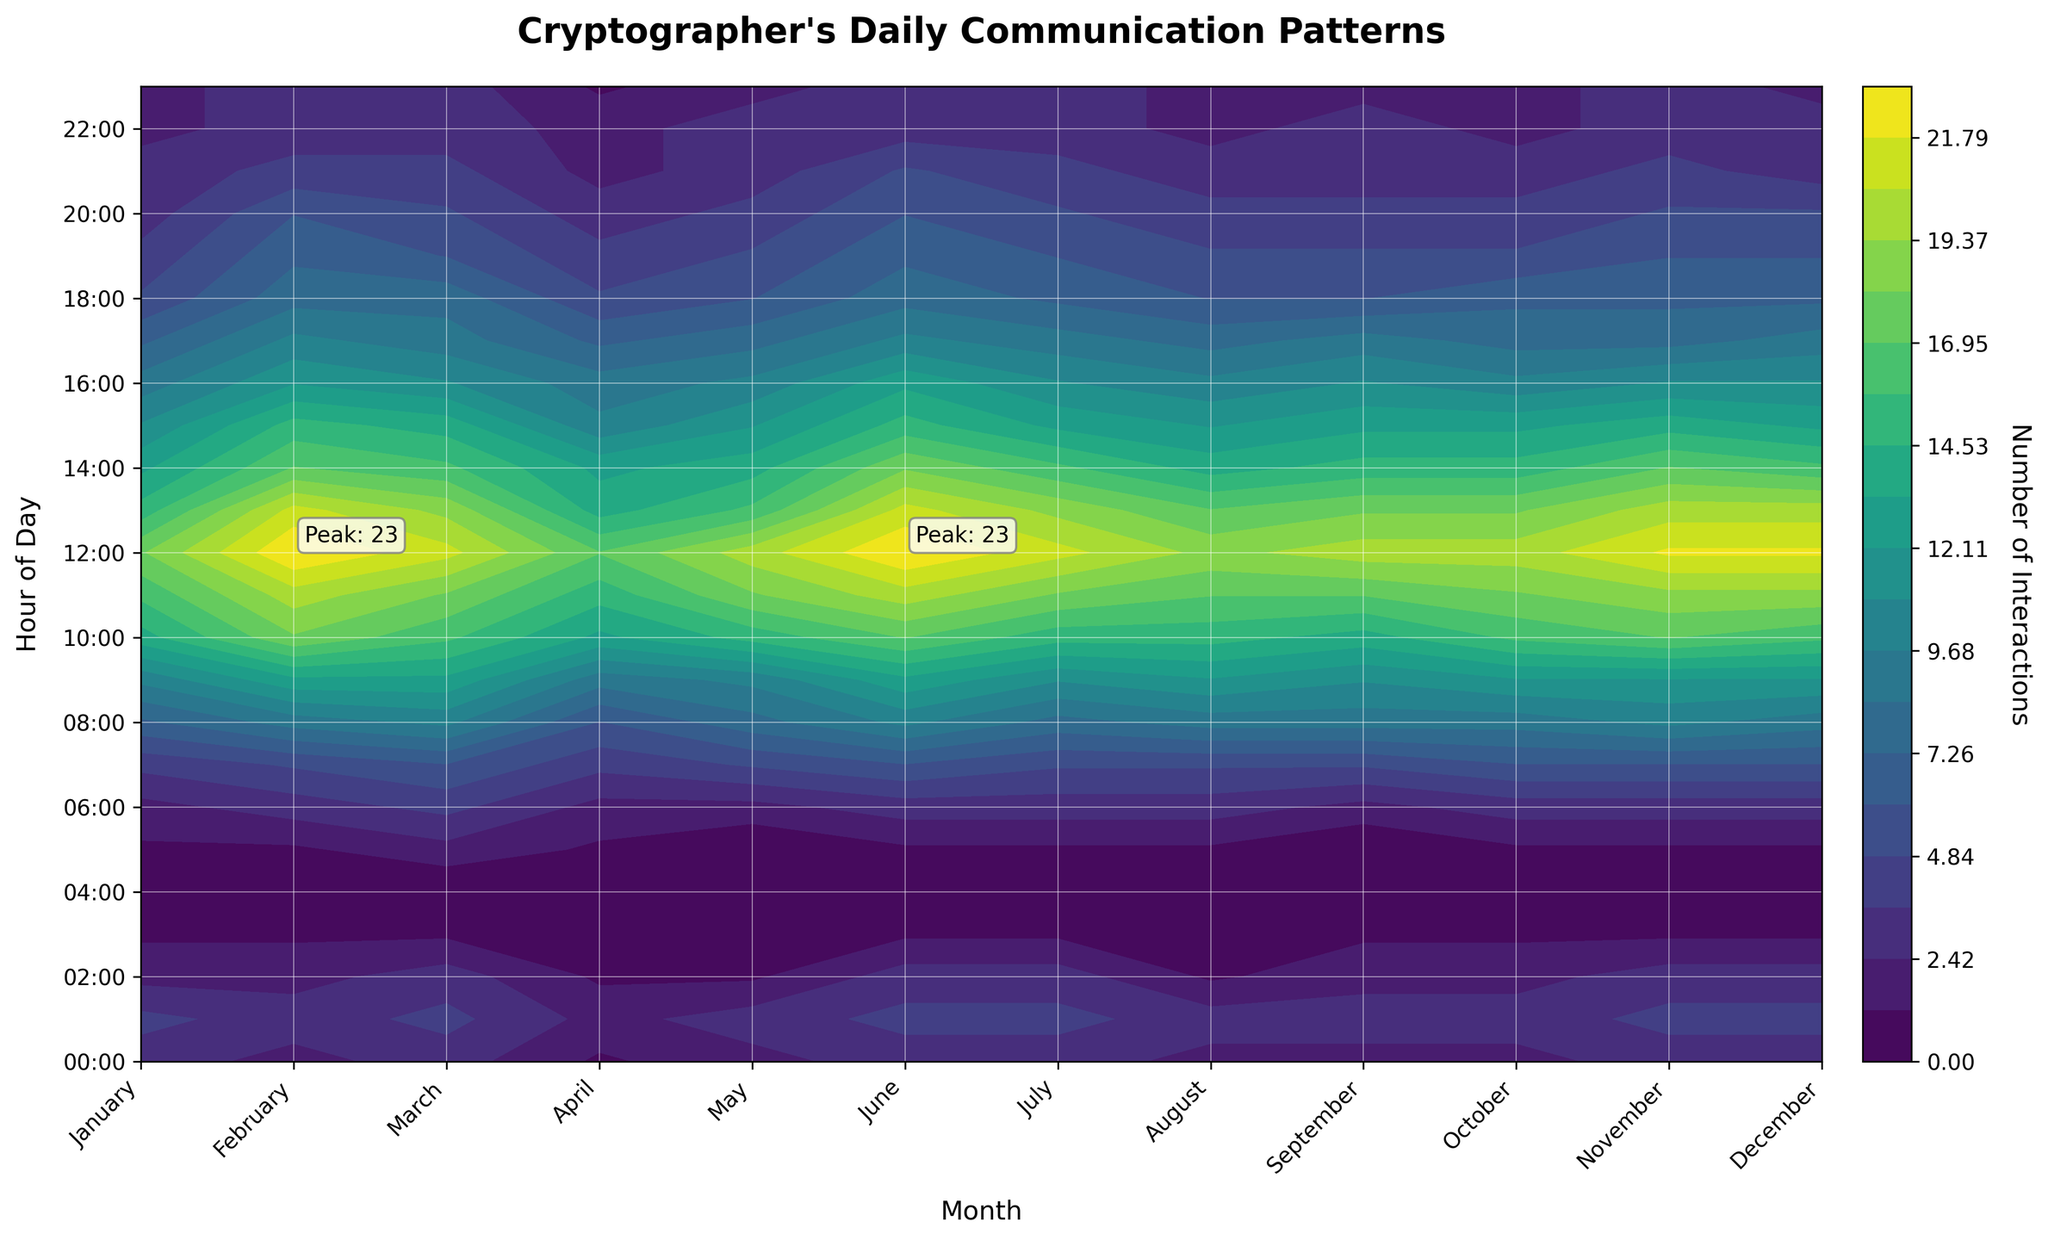What is the title of the plot? The title is usually found at the top of the plot. It gives an overview of what the plot represents. Here, the title "Cryptographer's Daily Communication Patterns" is shown clearly on top.
Answer: Cryptographer's Daily Communication Patterns What do the x-axis labels represent? By examining the x-axis labels, we can see they represent the months of the year (e.g., January, February, etc.).
Answer: Months What do the y-axis labels represent? The y-axis labels list hours of the day in a time format ranging from 00:00 (midnight) to 23:00 (11 PM).
Answer: Hours of Day What is the color bar on the right indicating? The color bar on the right represents the number of interactions, indicated by the label next to it and the gradient colors denoted in the legend.
Answer: Number of Interactions During which hour is the peak interaction in April? By examining the contour plot and focusing on April, you can see the annotated peak interaction time. The label reveals that the peak interaction occurs at 12:00-13:00 in April.
Answer: 12:00-13:00 What are the peak interaction values annotated as? Peak interaction values are highlighted directly on the plot with annotations indicating their exact number. For example, "Peak: 23" is noted where interactions are the highest.
Answer: Peak: 23 Which months have interactions peaking at 12:00? By looking at the labels and annotations for different months, you can identify the peaks. Interactions peak at 12:00 in months like April, May, June, July, and August.
Answer: April, May, June, July, August Which hour has more interactions on average, 10:00 or 15:00? On average, interaction levels at different times can be compared by looking at a specific color contour for each hour across all months. 10:00 displays significantly higher average interactions compared to 15:00.
Answer: 10:00 In which month does the cryptographer have the least interactions at 06:00? To find the least interactions at 06:00, observe the contours at 06:00 for the months. The lightest color indicates January as the month with the least interactions.
Answer: January Comparing March and September, which month experiences a higher number of interactions overall? Comparing the overall color intensities between March and September, the contours signal that both months have similar interaction patterns, but with slight differences, March having slightly higher peaks in March.
Answer: March 